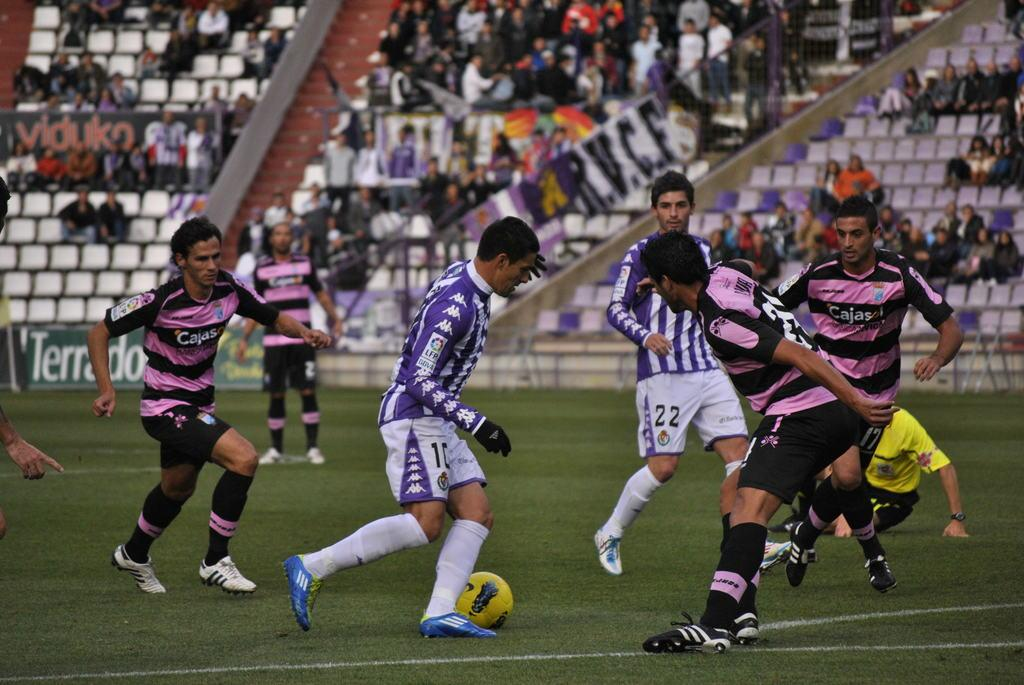What activity are the group of people engaged in within the image? The group of people are playing football in the image. Can you describe the action of one person in the image? One person is trying to kick the football. What is the person wearing on their body? The person is wearing a purple and white dress. What type of footwear is the person wearing? The person is wearing blue shoes. What type of wax is being used to create the legs of the person in the image? There is no wax present in the image, nor is there any indication that the person's legs are made of wax. Is the person wearing a hat in the image? There is no hat visible in the image. 